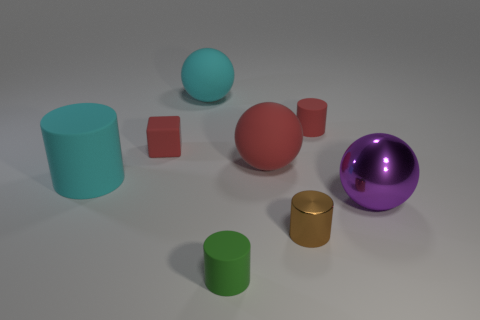There is a big purple thing that is the same shape as the big red rubber object; what is its material?
Give a very brief answer. Metal. The shiny cylinder has what color?
Ensure brevity in your answer.  Brown. What number of things are small brown metallic things or large cyan things?
Provide a succinct answer. 3. What is the shape of the tiny rubber thing left of the cyan matte thing that is behind the large cyan matte cylinder?
Your answer should be very brief. Cube. What number of other things are there of the same material as the tiny block
Keep it short and to the point. 5. Does the large cyan ball have the same material as the cyan cylinder that is to the left of the tiny red matte cylinder?
Provide a succinct answer. Yes. How many things are either big purple shiny balls that are to the right of the cyan cylinder or balls that are on the left side of the small red cylinder?
Provide a short and direct response. 3. How many other objects are there of the same color as the large matte cylinder?
Your answer should be very brief. 1. Is the number of small matte cylinders in front of the purple thing greater than the number of cyan spheres right of the tiny red rubber cylinder?
Ensure brevity in your answer.  Yes. How many spheres are either small yellow shiny things or big cyan rubber things?
Offer a very short reply. 1. 